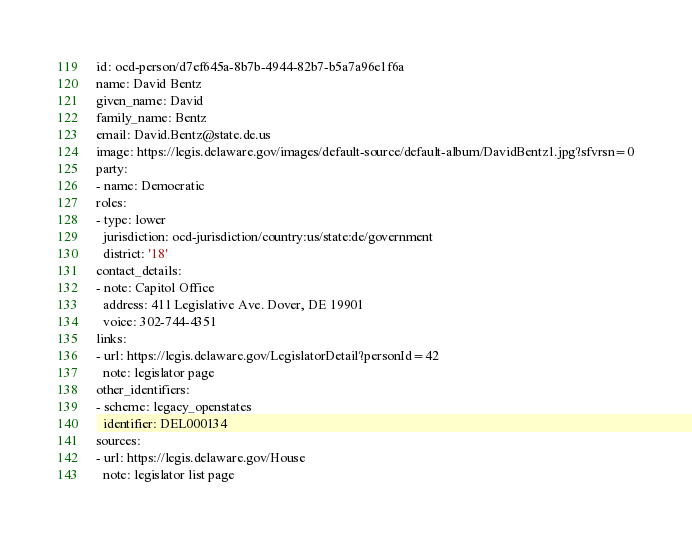Convert code to text. <code><loc_0><loc_0><loc_500><loc_500><_YAML_>id: ocd-person/d7ef645a-8b7b-4944-82b7-b5a7a96e1f6a
name: David Bentz
given_name: David
family_name: Bentz
email: David.Bentz@state.de.us
image: https://legis.delaware.gov/images/default-source/default-album/DavidBentz1.jpg?sfvrsn=0
party:
- name: Democratic
roles:
- type: lower
  jurisdiction: ocd-jurisdiction/country:us/state:de/government
  district: '18'
contact_details:
- note: Capitol Office
  address: 411 Legislative Ave. Dover, DE 19901
  voice: 302-744-4351
links:
- url: https://legis.delaware.gov/LegislatorDetail?personId=42
  note: legislator page
other_identifiers:
- scheme: legacy_openstates
  identifier: DEL000134
sources:
- url: https://legis.delaware.gov/House
  note: legislator list page
</code> 